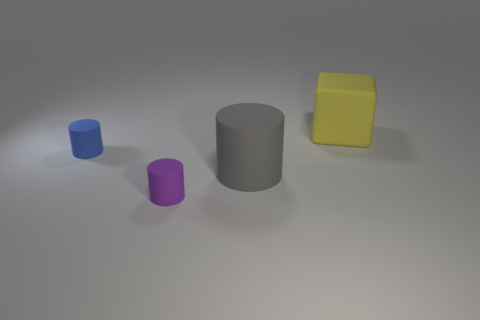Can you describe the lighting in the scene? The lighting in the scene appears to be coming from a single overhead source, as indicated by the soft shadows each object casts on the ground. 